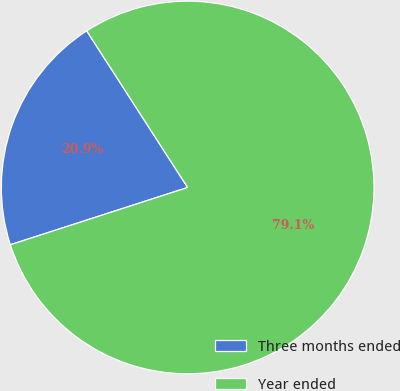Convert chart to OTSL. <chart><loc_0><loc_0><loc_500><loc_500><pie_chart><fcel>Three months ended<fcel>Year ended<nl><fcel>20.86%<fcel>79.14%<nl></chart> 